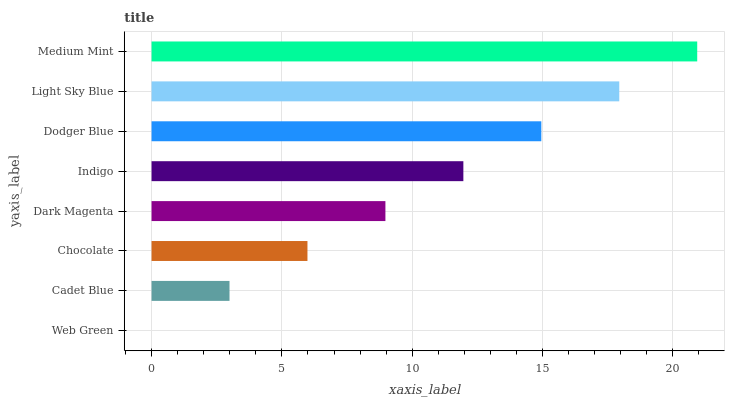Is Web Green the minimum?
Answer yes or no. Yes. Is Medium Mint the maximum?
Answer yes or no. Yes. Is Cadet Blue the minimum?
Answer yes or no. No. Is Cadet Blue the maximum?
Answer yes or no. No. Is Cadet Blue greater than Web Green?
Answer yes or no. Yes. Is Web Green less than Cadet Blue?
Answer yes or no. Yes. Is Web Green greater than Cadet Blue?
Answer yes or no. No. Is Cadet Blue less than Web Green?
Answer yes or no. No. Is Indigo the high median?
Answer yes or no. Yes. Is Dark Magenta the low median?
Answer yes or no. Yes. Is Dark Magenta the high median?
Answer yes or no. No. Is Indigo the low median?
Answer yes or no. No. 